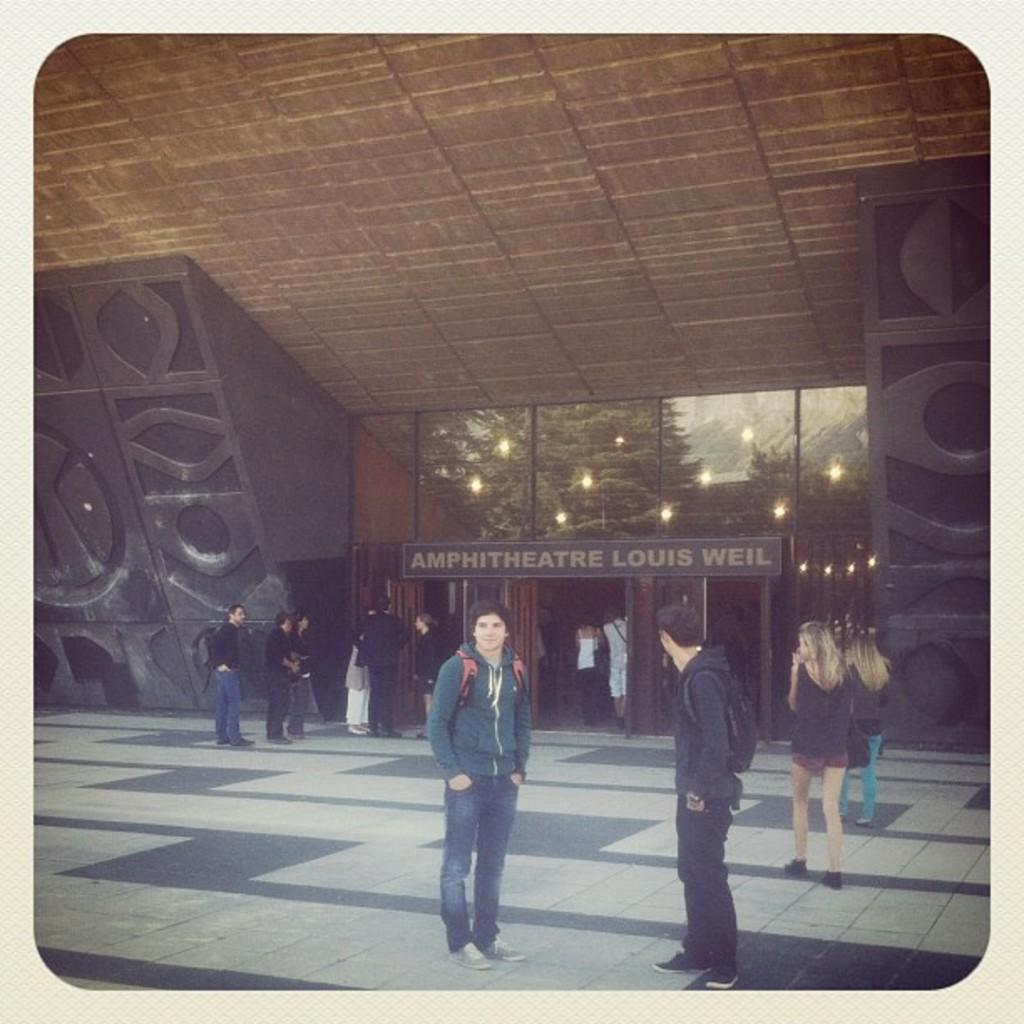Can you describe this image briefly? Here in this picture we can see some people standing and walking on the ground over there and behind them we can see an amphitheater present, as we can see the board of it on the building present over there and inside it we can see lights present on the roof all over there. 